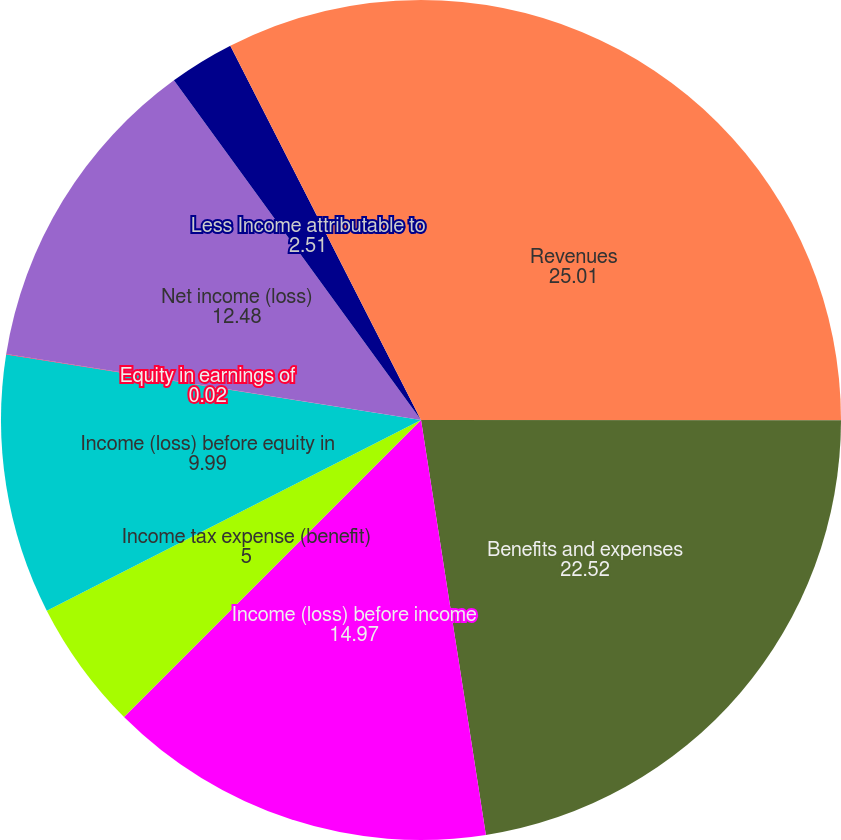Convert chart to OTSL. <chart><loc_0><loc_0><loc_500><loc_500><pie_chart><fcel>Revenues<fcel>Benefits and expenses<fcel>Income (loss) before income<fcel>Income tax expense (benefit)<fcel>Income (loss) before equity in<fcel>Equity in earnings of<fcel>Net income (loss)<fcel>Less Income attributable to<fcel>Net income (loss) attributable<nl><fcel>25.01%<fcel>22.52%<fcel>14.97%<fcel>5.0%<fcel>9.99%<fcel>0.02%<fcel>12.48%<fcel>2.51%<fcel>7.5%<nl></chart> 